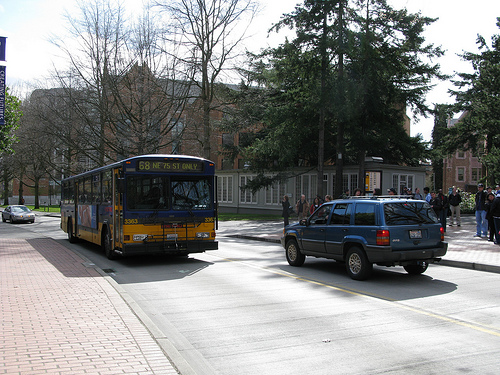How many buses? 1 